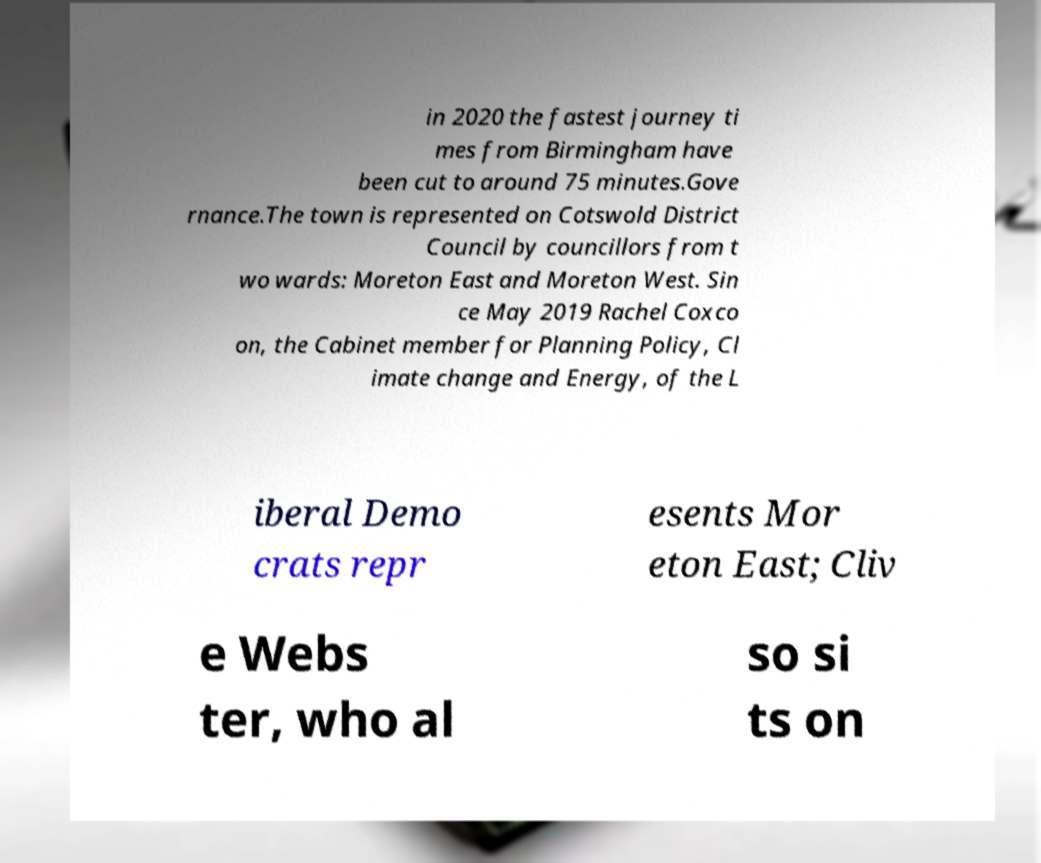Please identify and transcribe the text found in this image. in 2020 the fastest journey ti mes from Birmingham have been cut to around 75 minutes.Gove rnance.The town is represented on Cotswold District Council by councillors from t wo wards: Moreton East and Moreton West. Sin ce May 2019 Rachel Coxco on, the Cabinet member for Planning Policy, Cl imate change and Energy, of the L iberal Demo crats repr esents Mor eton East; Cliv e Webs ter, who al so si ts on 